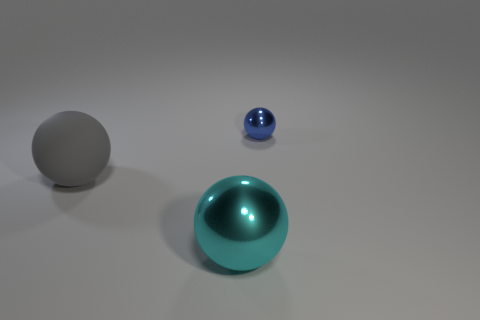What time of day does the lighting in the scene suggest? The lighting in the scene is neutral and does not strongly suggest any particular time of day, as it appears to be a controlled studio environment with consistent and soft light sources. 